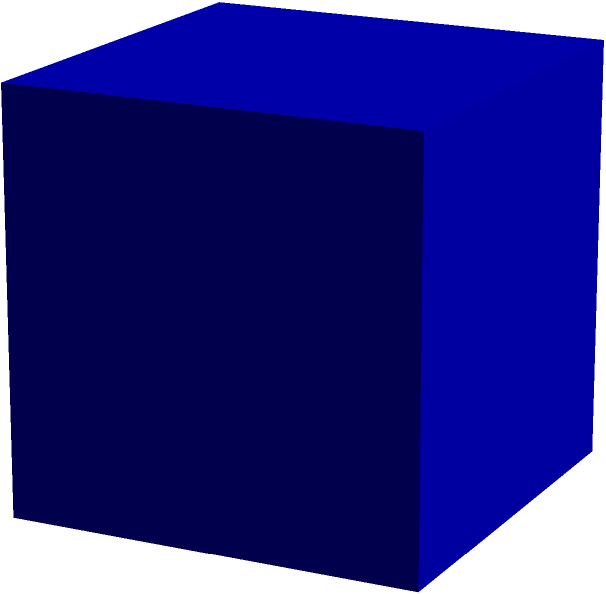You need to create a cube-shaped storage box for fabric samples. If the length of each edge of the box is $a$ inches, what is the total surface area of the box in square inches? To find the surface area of a cube, we need to follow these steps:

1. Identify the number of faces: A cube has 6 faces.

2. Calculate the area of one face:
   - Each face is a square with side length $a$.
   - Area of one face = $a^2$ square inches.

3. Calculate the total surface area:
   - Total surface area = Area of one face × Number of faces
   - Total surface area = $a^2 \times 6 = 6a^2$ square inches

Therefore, the total surface area of the cube-shaped storage box is $6a^2$ square inches, where $a$ is the length of each edge in inches.
Answer: $6a^2$ square inches 